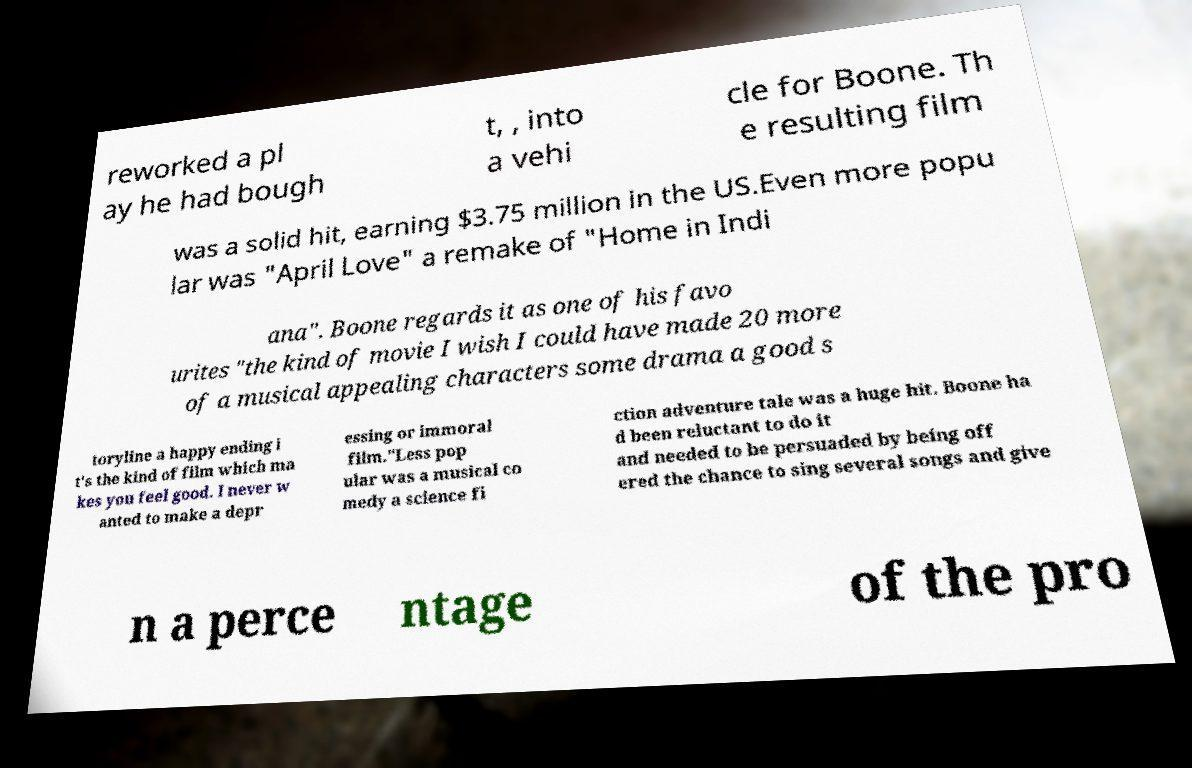What messages or text are displayed in this image? I need them in a readable, typed format. reworked a pl ay he had bough t, , into a vehi cle for Boone. Th e resulting film was a solid hit, earning $3.75 million in the US.Even more popu lar was "April Love" a remake of "Home in Indi ana". Boone regards it as one of his favo urites "the kind of movie I wish I could have made 20 more of a musical appealing characters some drama a good s toryline a happy ending i t's the kind of film which ma kes you feel good. I never w anted to make a depr essing or immoral film."Less pop ular was a musical co medy a science fi ction adventure tale was a huge hit. Boone ha d been reluctant to do it and needed to be persuaded by being off ered the chance to sing several songs and give n a perce ntage of the pro 